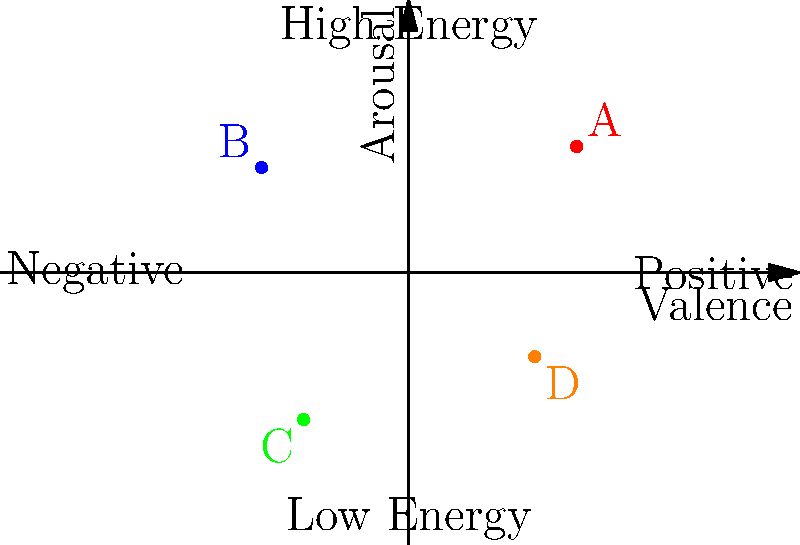As a music supervisor, you're analyzing a valence-arousal graph for potential tracks to use in a commercial. Based on the graph, which song would be most suitable for an upbeat, energetic advertisement promoting a new sports drink? To answer this question, we need to understand the valence-arousal model and interpret the graph:

1. The valence-arousal model is used to represent emotional states in music:
   - Valence (x-axis) represents the positivity or negativity of the emotion.
   - Arousal (y-axis) represents the energy or intensity of the emotion.

2. For an upbeat, energetic advertisement, we need a song with:
   - High arousal (high energy)
   - Positive valence (positive emotion)

3. Analyzing the points on the graph:
   - Point A (0.8, 0.6): High positive valence, high arousal
   - Point B (-0.7, 0.5): Negative valence, high arousal
   - Point C (-0.5, -0.7): Negative valence, low arousal
   - Point D (0.6, -0.4): Positive valence, low arousal

4. Comparing the points:
   - Point A is in the upper-right quadrant, indicating high energy and positive emotion.
   - Points B and C have negative valence, making them unsuitable for an upbeat advertisement.
   - Point D has positive valence but low arousal, which doesn't match the energetic requirement.

5. Conclusion: Point A represents the song that best fits the criteria for an upbeat, energetic advertisement promoting a sports drink.
Answer: A 